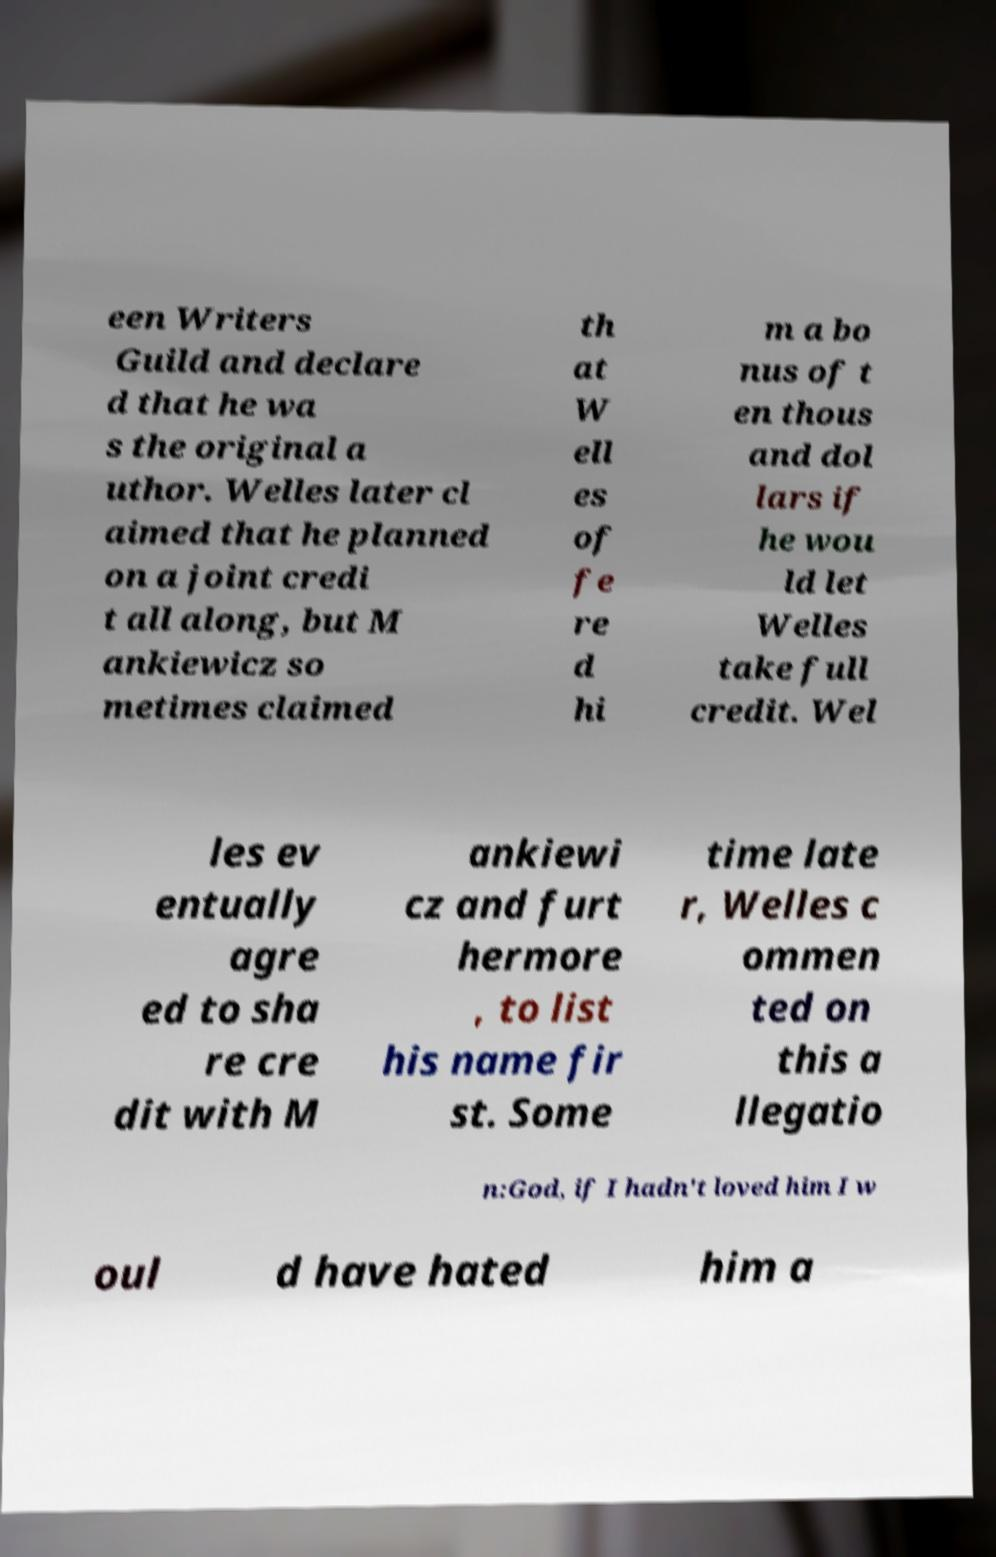Can you read and provide the text displayed in the image?This photo seems to have some interesting text. Can you extract and type it out for me? een Writers Guild and declare d that he wa s the original a uthor. Welles later cl aimed that he planned on a joint credi t all along, but M ankiewicz so metimes claimed th at W ell es of fe re d hi m a bo nus of t en thous and dol lars if he wou ld let Welles take full credit. Wel les ev entually agre ed to sha re cre dit with M ankiewi cz and furt hermore , to list his name fir st. Some time late r, Welles c ommen ted on this a llegatio n:God, if I hadn't loved him I w oul d have hated him a 